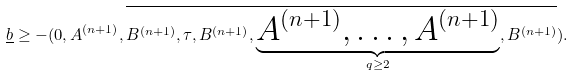<formula> <loc_0><loc_0><loc_500><loc_500>\underline { b } \geq - ( 0 , A ^ { ( n + 1 ) } , \overline { B ^ { ( n + 1 ) } , \tau , B ^ { ( n + 1 ) } , \underbrace { A ^ { ( n + 1 ) } , \dots , A ^ { ( n + 1 ) } } _ { q \geq 2 } , B ^ { ( n + 1 ) } } ) .</formula> 